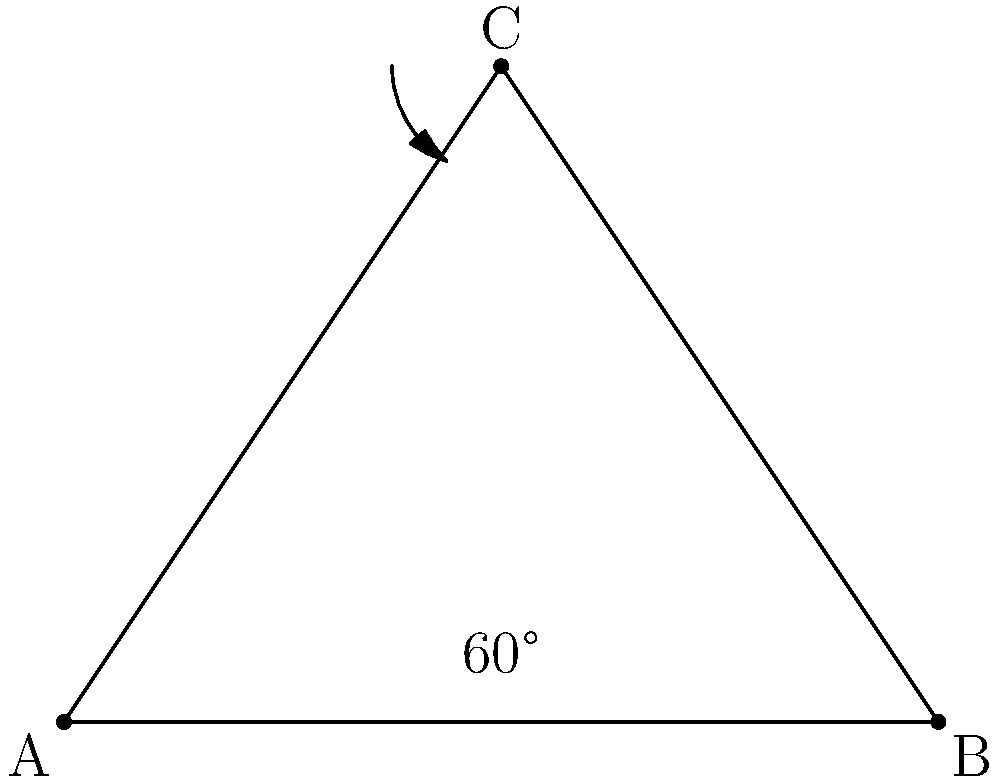In developing a video conferencing feature for Tiki Groupware, you need to calculate the viewing angle of a webcam. Given the diagram where the webcam is positioned at point C and its field of view is represented by the triangle ABC, with angle ACB measuring 60°, what is the total viewing angle of the webcam? To find the total viewing angle of the webcam, we need to follow these steps:

1. Identify the given information:
   - The webcam is positioned at point C
   - The field of view is represented by triangle ABC
   - Angle ACB measures 60°

2. Recall that in a triangle, the sum of all interior angles is always 180°.

3. In an isosceles triangle, the base angles are equal. Since the webcam's field of view is typically symmetrical, we can assume triangle ABC is isosceles with CA = CB.

4. Let's denote the base angles (CAB and CBA) as x°. We can now set up an equation:
   $$x° + x° + 60° = 180°$$

5. Simplify the equation:
   $$2x° + 60° = 180°$$

6. Solve for x:
   $$2x° = 120°$$
   $$x° = 60°$$

7. The viewing angle of the webcam is the angle at point C, which is 60°.

8. However, the question asks for the total viewing angle, which is twice this angle:
   $$\text{Total viewing angle} = 2 \times 60° = 120°$$

Therefore, the total viewing angle of the webcam is 120°.
Answer: 120° 